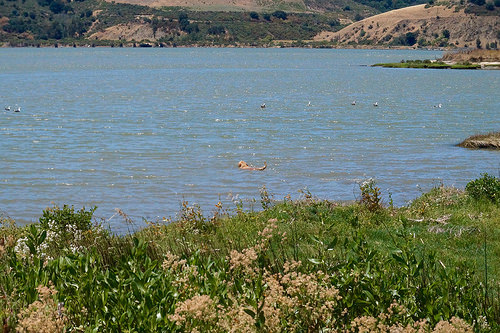<image>
Is there a water next to the grass? Yes. The water is positioned adjacent to the grass, located nearby in the same general area. 